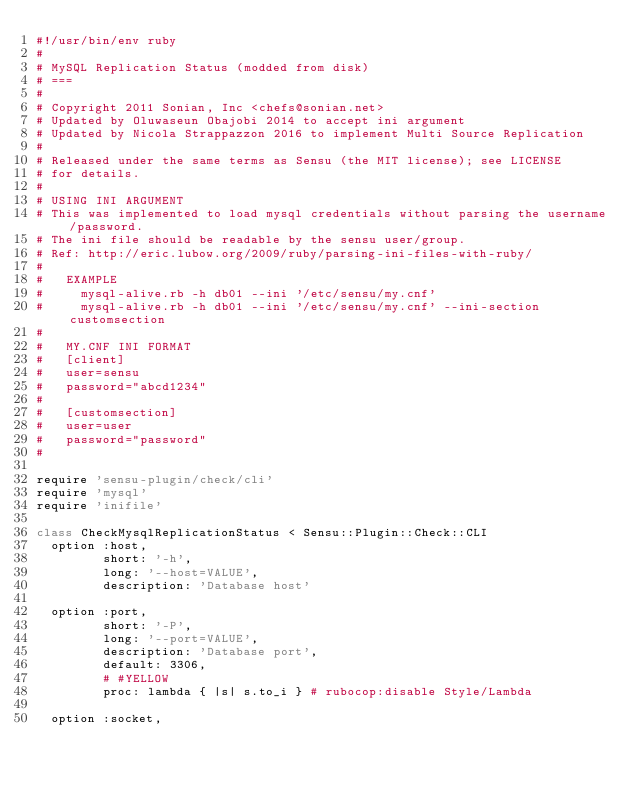<code> <loc_0><loc_0><loc_500><loc_500><_Ruby_>#!/usr/bin/env ruby
#
# MySQL Replication Status (modded from disk)
# ===
#
# Copyright 2011 Sonian, Inc <chefs@sonian.net>
# Updated by Oluwaseun Obajobi 2014 to accept ini argument
# Updated by Nicola Strappazzon 2016 to implement Multi Source Replication
#
# Released under the same terms as Sensu (the MIT license); see LICENSE
# for details.
#
# USING INI ARGUMENT
# This was implemented to load mysql credentials without parsing the username/password.
# The ini file should be readable by the sensu user/group.
# Ref: http://eric.lubow.org/2009/ruby/parsing-ini-files-with-ruby/
#
#   EXAMPLE
#     mysql-alive.rb -h db01 --ini '/etc/sensu/my.cnf'
#     mysql-alive.rb -h db01 --ini '/etc/sensu/my.cnf' --ini-section customsection
#
#   MY.CNF INI FORMAT
#   [client]
#   user=sensu
#   password="abcd1234"
#
#   [customsection]
#   user=user
#   password="password"
#

require 'sensu-plugin/check/cli'
require 'mysql'
require 'inifile'

class CheckMysqlReplicationStatus < Sensu::Plugin::Check::CLI
  option :host,
         short: '-h',
         long: '--host=VALUE',
         description: 'Database host'

  option :port,
         short: '-P',
         long: '--port=VALUE',
         description: 'Database port',
         default: 3306,
         # #YELLOW
         proc: lambda { |s| s.to_i } # rubocop:disable Style/Lambda

  option :socket,</code> 